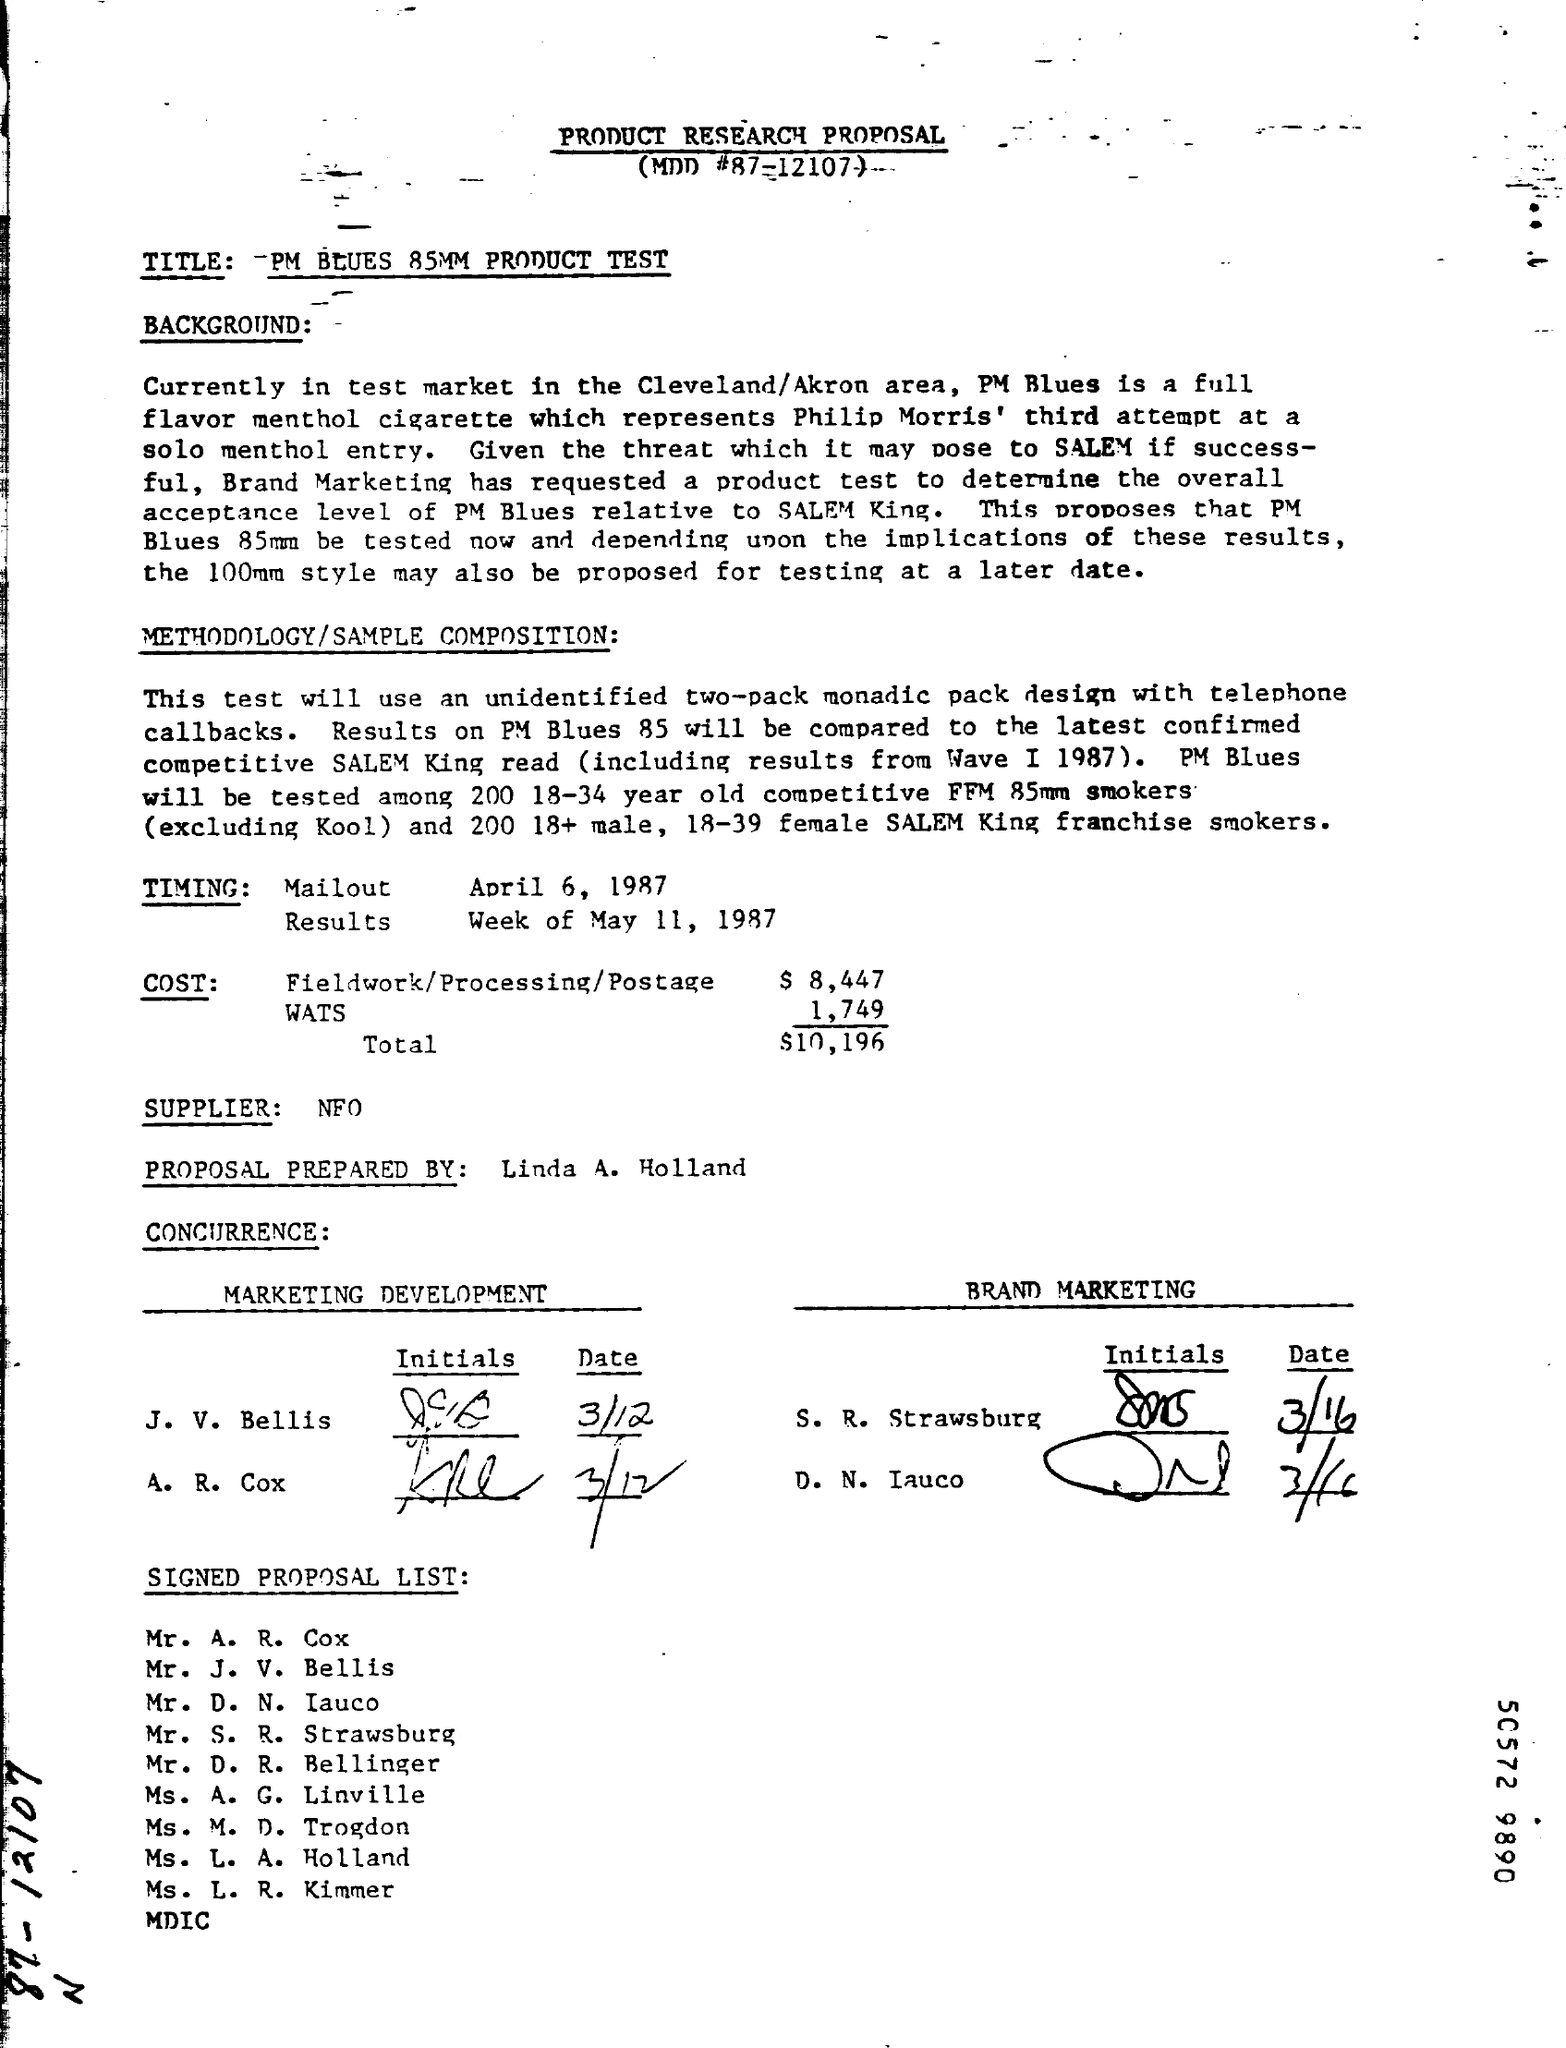Highlight a few significant elements in this photo. The supplier mentioned in the given proposal is NFO. According to the provided proposal, the total cost is $10,196. The timing of results, as specified in the given proposal, is the week of May 11, 1987. The cost of fieldwork, processing, and postage, as specified in the proposal, is $8,447. The timing of the mailout, as specified in the given proposal, is April 6, 1987. 